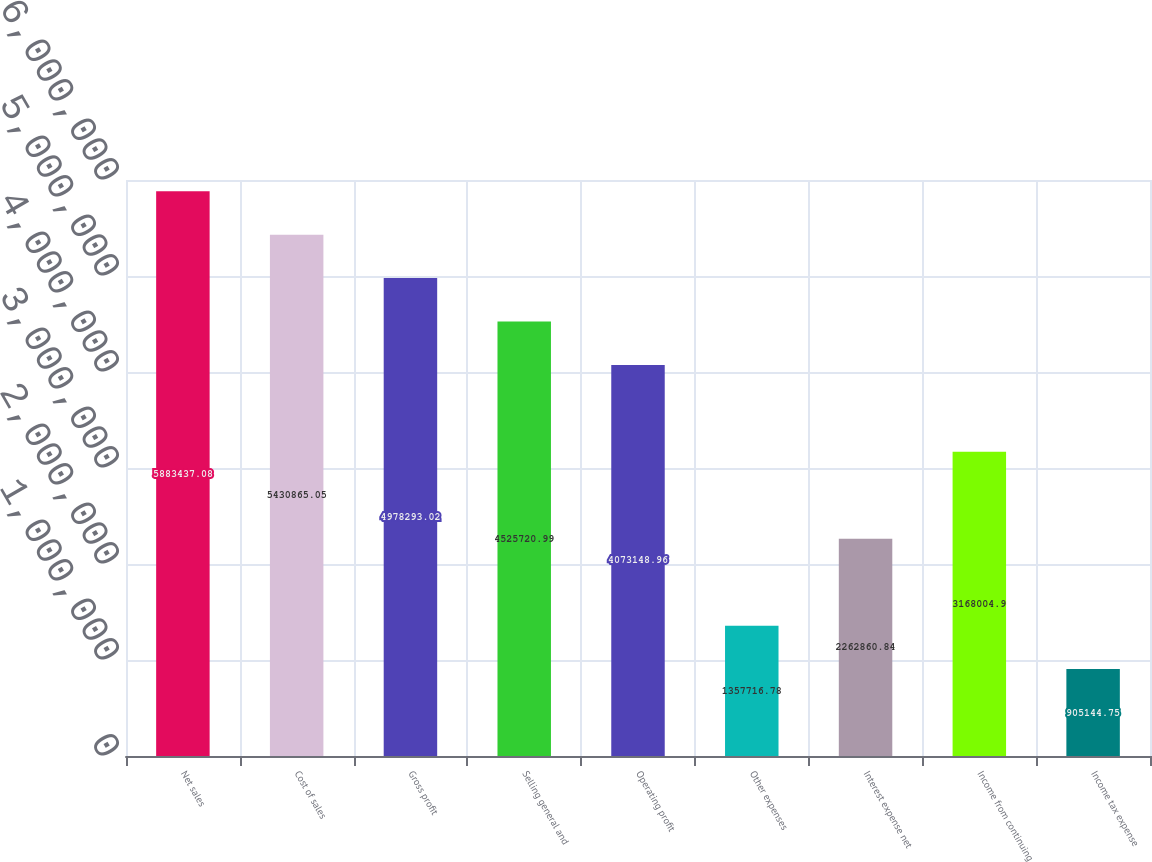<chart> <loc_0><loc_0><loc_500><loc_500><bar_chart><fcel>Net sales<fcel>Cost of sales<fcel>Gross profit<fcel>Selling general and<fcel>Operating profit<fcel>Other expenses<fcel>Interest expense net<fcel>Income from continuing<fcel>Income tax expense<nl><fcel>5.88344e+06<fcel>5.43087e+06<fcel>4.97829e+06<fcel>4.52572e+06<fcel>4.07315e+06<fcel>1.35772e+06<fcel>2.26286e+06<fcel>3.168e+06<fcel>905145<nl></chart> 